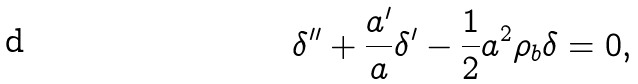Convert formula to latex. <formula><loc_0><loc_0><loc_500><loc_500>\delta ^ { \prime \prime } + \frac { a ^ { \prime } } { a } \delta ^ { \prime } - \frac { 1 } { 2 } a ^ { 2 } \rho _ { b } \delta = 0 ,</formula> 